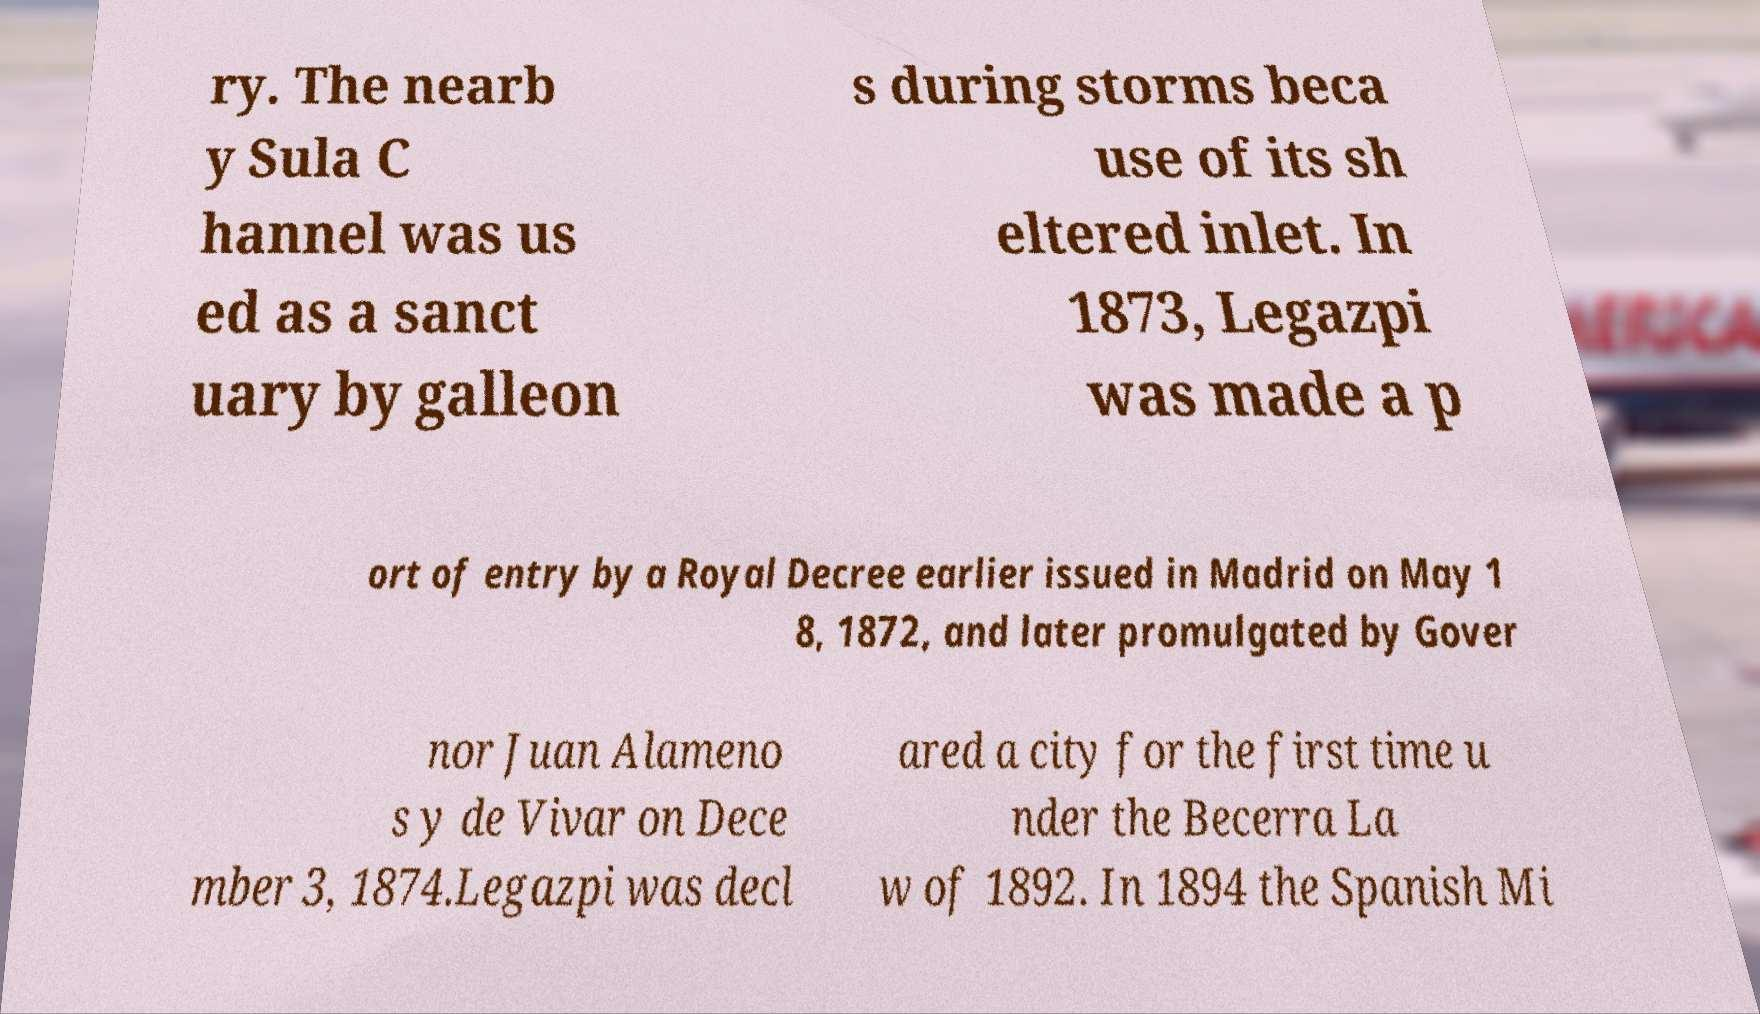I need the written content from this picture converted into text. Can you do that? ry. The nearb y Sula C hannel was us ed as a sanct uary by galleon s during storms beca use of its sh eltered inlet. In 1873, Legazpi was made a p ort of entry by a Royal Decree earlier issued in Madrid on May 1 8, 1872, and later promulgated by Gover nor Juan Alameno s y de Vivar on Dece mber 3, 1874.Legazpi was decl ared a city for the first time u nder the Becerra La w of 1892. In 1894 the Spanish Mi 